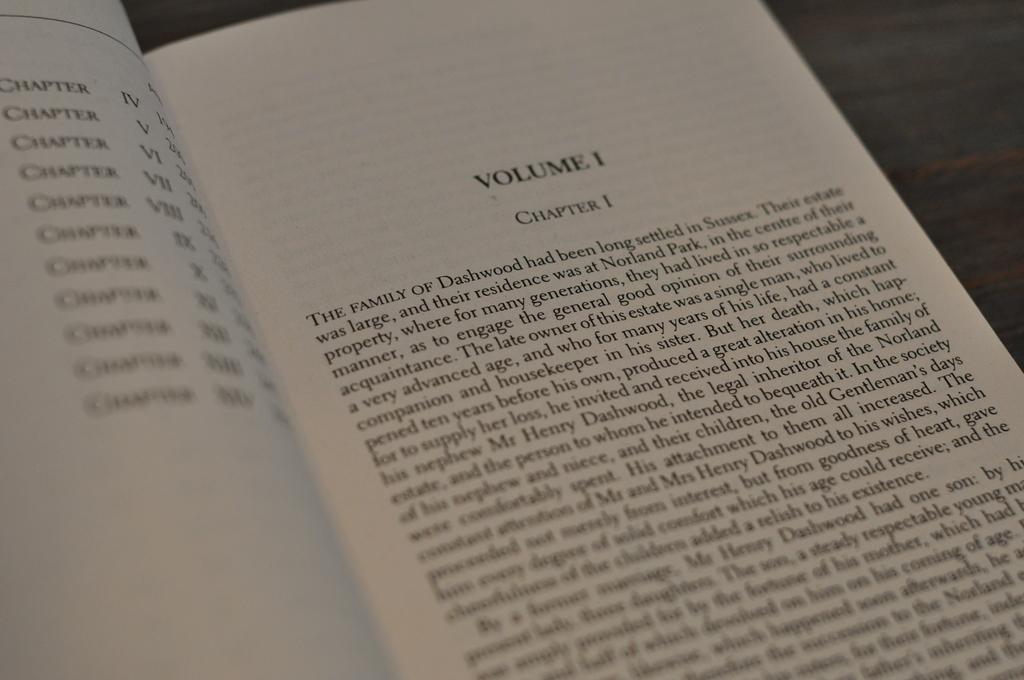What is the volume 1 about?
Keep it short and to the point. The family of dashwood. What chapter is on this page?
Ensure brevity in your answer.  1. 